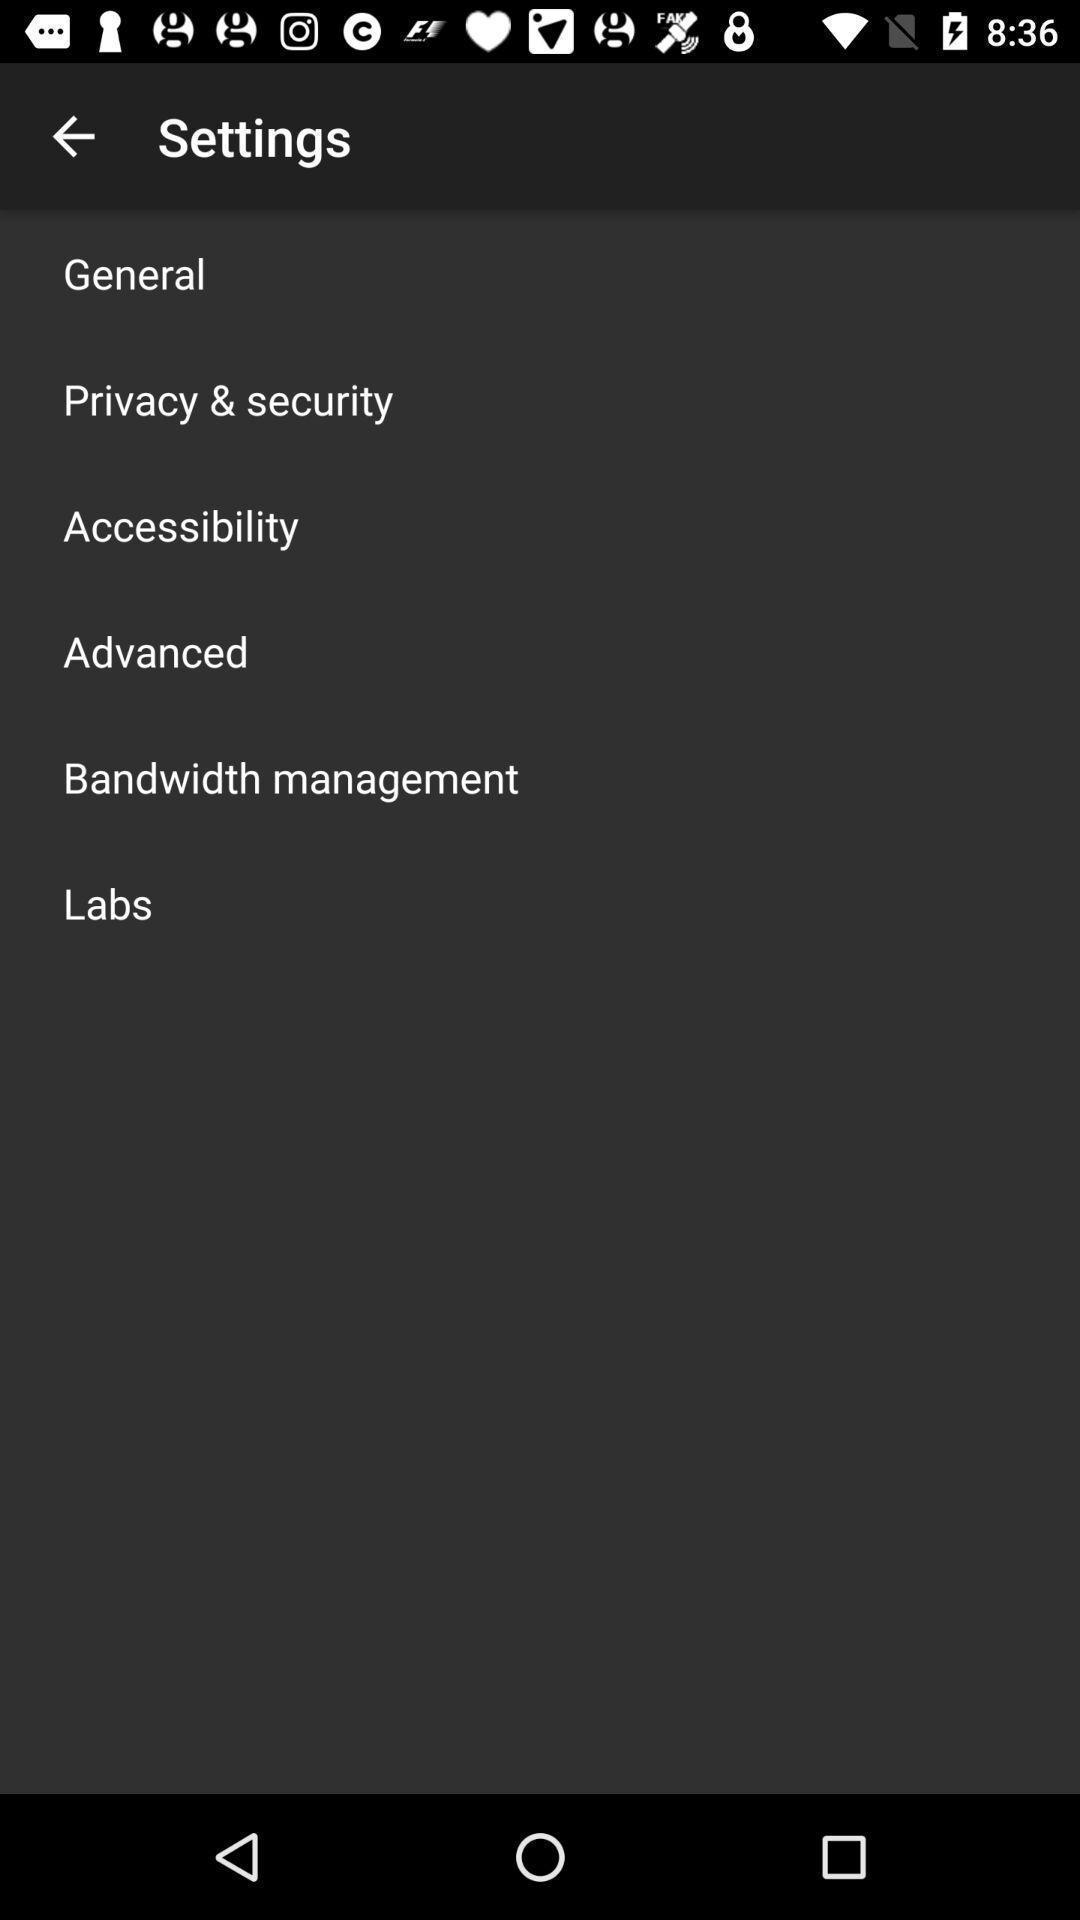What can you discern from this picture? Screen showing settings page. 